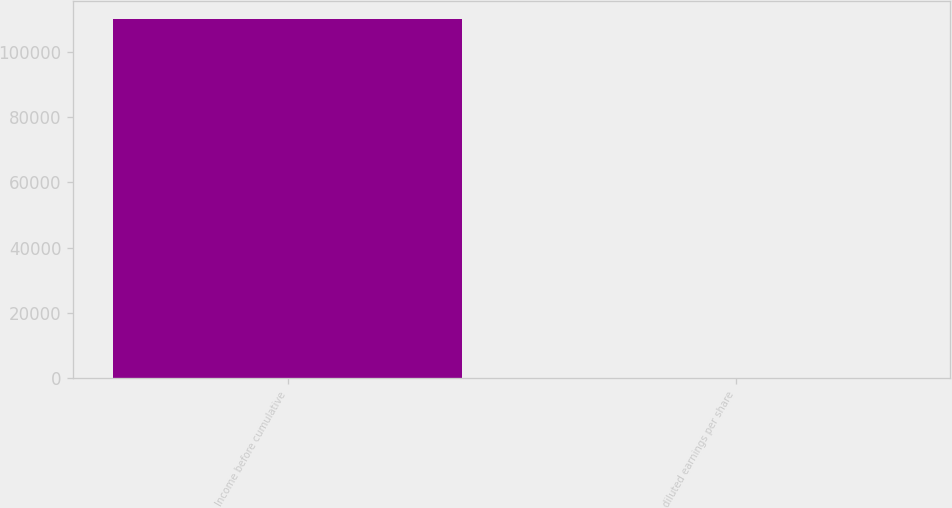Convert chart to OTSL. <chart><loc_0><loc_0><loc_500><loc_500><bar_chart><fcel>Income before cumulative<fcel>diluted earnings per share<nl><fcel>110113<fcel>1.6<nl></chart> 